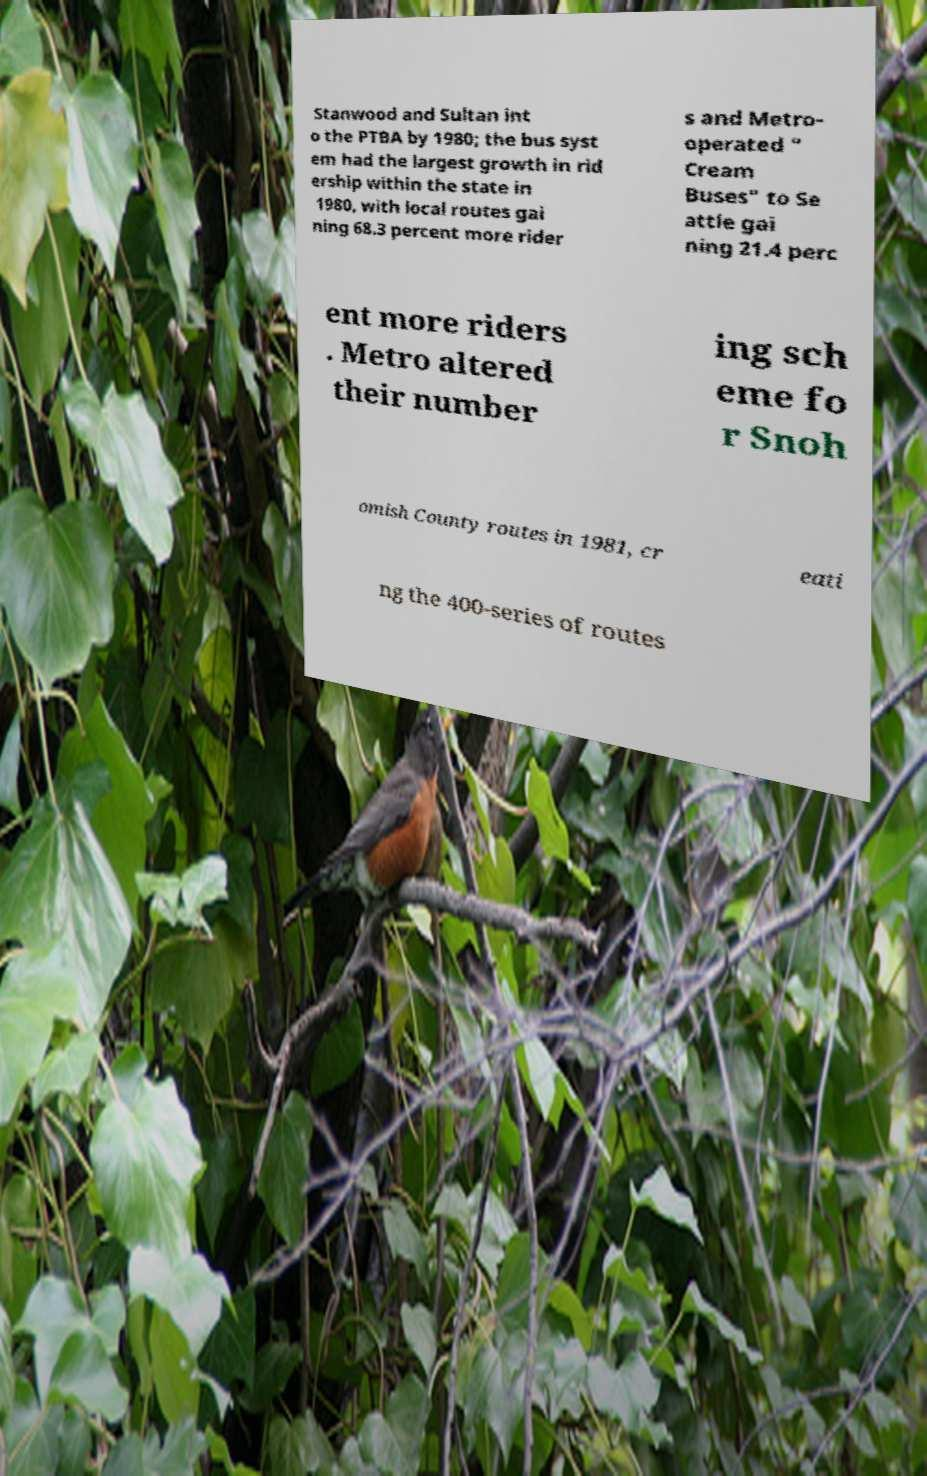Could you extract and type out the text from this image? Stanwood and Sultan int o the PTBA by 1980; the bus syst em had the largest growth in rid ership within the state in 1980, with local routes gai ning 68.3 percent more rider s and Metro- operated " Cream Buses" to Se attle gai ning 21.4 perc ent more riders . Metro altered their number ing sch eme fo r Snoh omish County routes in 1981, cr eati ng the 400-series of routes 